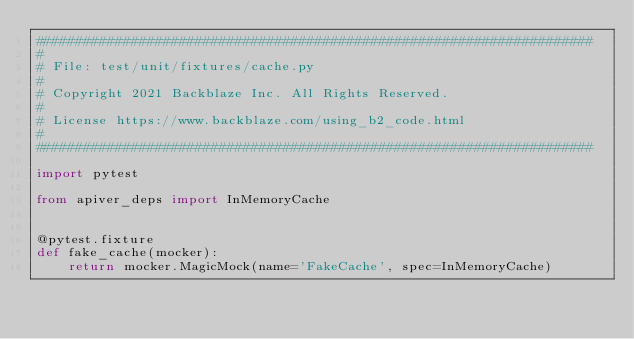Convert code to text. <code><loc_0><loc_0><loc_500><loc_500><_Python_>######################################################################
#
# File: test/unit/fixtures/cache.py
#
# Copyright 2021 Backblaze Inc. All Rights Reserved.
#
# License https://www.backblaze.com/using_b2_code.html
#
######################################################################

import pytest

from apiver_deps import InMemoryCache


@pytest.fixture
def fake_cache(mocker):
    return mocker.MagicMock(name='FakeCache', spec=InMemoryCache)
</code> 